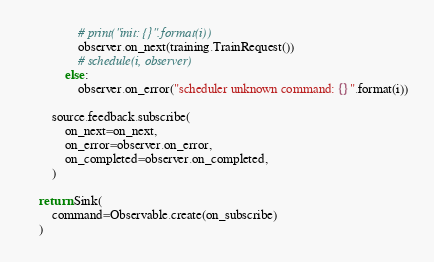Convert code to text. <code><loc_0><loc_0><loc_500><loc_500><_Python_>                # print("init: {}".format(i))
                observer.on_next(training.TrainRequest())
                # schedule(i, observer)
            else:
                observer.on_error("scheduler unknown command: {}".format(i))

        source.feedback.subscribe(
            on_next=on_next,
            on_error=observer.on_error,
            on_completed=observer.on_completed,
        )

    return Sink(
        command=Observable.create(on_subscribe)
    )
</code> 